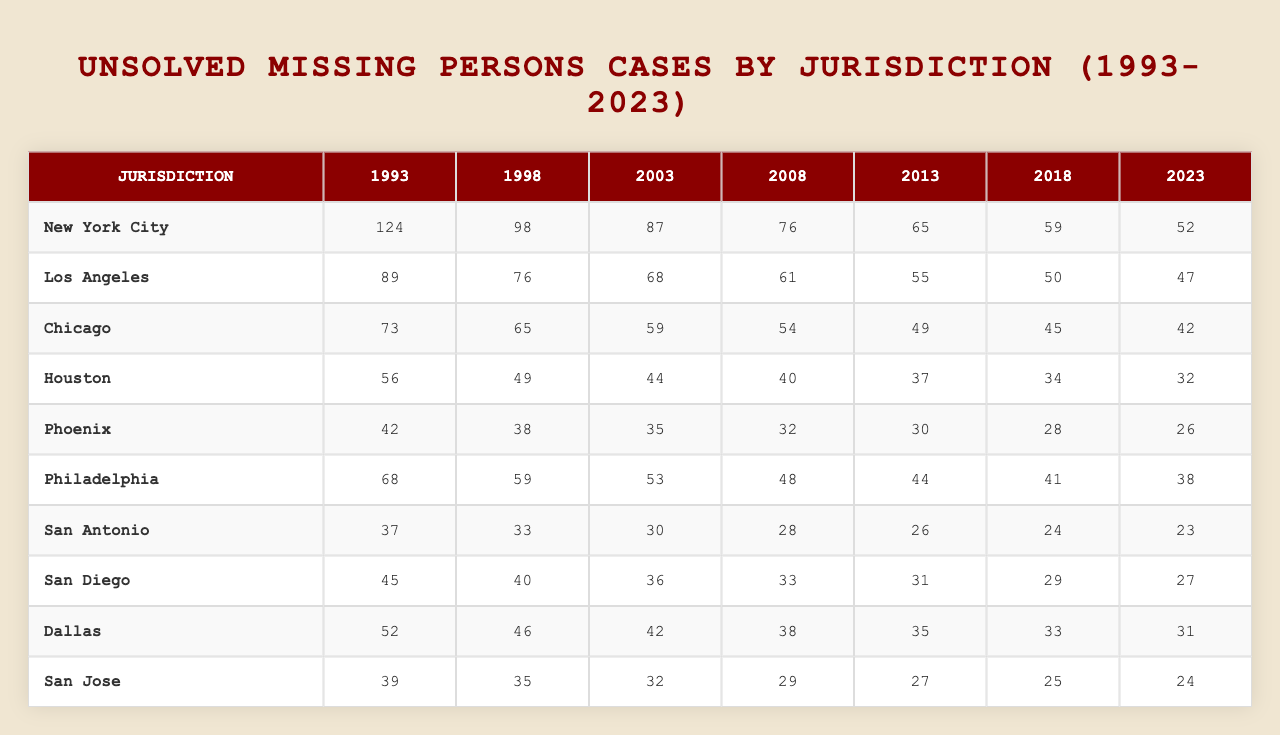What is the highest number of unsolved cases reported in New York City? Looking at the row for New York City, the highest number of unsolved cases is 124, which is the value for the year 1993.
Answer: 124 Which jurisdiction had the most unsolved cases in 2003? In the year 2003, New York City had the highest number of unsolved cases at 87.
Answer: New York City How many unsolved missing persons cases were reported in Chicago in 2018? Referring to the row for Chicago, the number of unsolved cases in 2018 is 45.
Answer: 45 What is the total number of unsolved cases across all jurisdictions in the year 2023? First, we sum the unsolved cases for all jurisdictions in 2023: 52 (NYC) + 47 (LA) + 42 (Chicago) + 32 (Houston) + 26 (Phoenix) + 38 (Philadelphia) + 23 (San Antonio) + 27 (San Diego) + 31 (Dallas) + 24 (San Jose) =  392.
Answer: 392 Which jurisdiction had the smallest number of unsolved cases in 2013? Looking at the row for 2013, Phoenix has the smallest number of unsolved cases at 30.
Answer: Phoenix How many fewer unsolved cases were there in Los Angeles in 1998 compared to San Antonio in the same year? In 1998, Los Angeles had 76 unsolved cases, and San Antonio had 33. The difference is 76 - 33 = 43.
Answer: 43 Which jurisdiction consistently had fewer than 50 unsolved cases from 2008 to 2023? Examining the rows from 2008 to 2023, San Antonio had fewer than 50 unsolved cases in all these years: 40, 37, 34, 32, 28, 26, 24.
Answer: San Antonio What is the average number of unsolved cases for all jurisdictions in the year 2008? Summing up the unsolved cases in 2008 gives: 76 (NYC) + 61 (LA) + 54 (Chicago) + 40 (Houston) + 32 (Phoenix) + 48 (Philadelphia) + 28 (San Antonio) + 33 (San Diego) + 38 (Dallas) + 29 (San Jose) = 409. Dividing by 10 gives an average of 40.9.
Answer: 40.9 Is it true that the number of unsolved cases in Philadelphia has decreased every five years since 1993? Checking the values for Philadelphia: 68 (1993), 59 (1998), 53 (2003), 48 (2008), 44 (2013), 41 (2018), 38 (2023). Each subsequent year does show a decrease, confirming the statement is true.
Answer: True What is the trend in unsolved cases for Phoenix over the years? The values for Phoenix show the following trend: 42 (1993), 38 (1998), 35 (2003), 32 (2008), 30 (2013), 28 (2018), 26 (2023), which indicates a consistent decline over the years.
Answer: Decline 